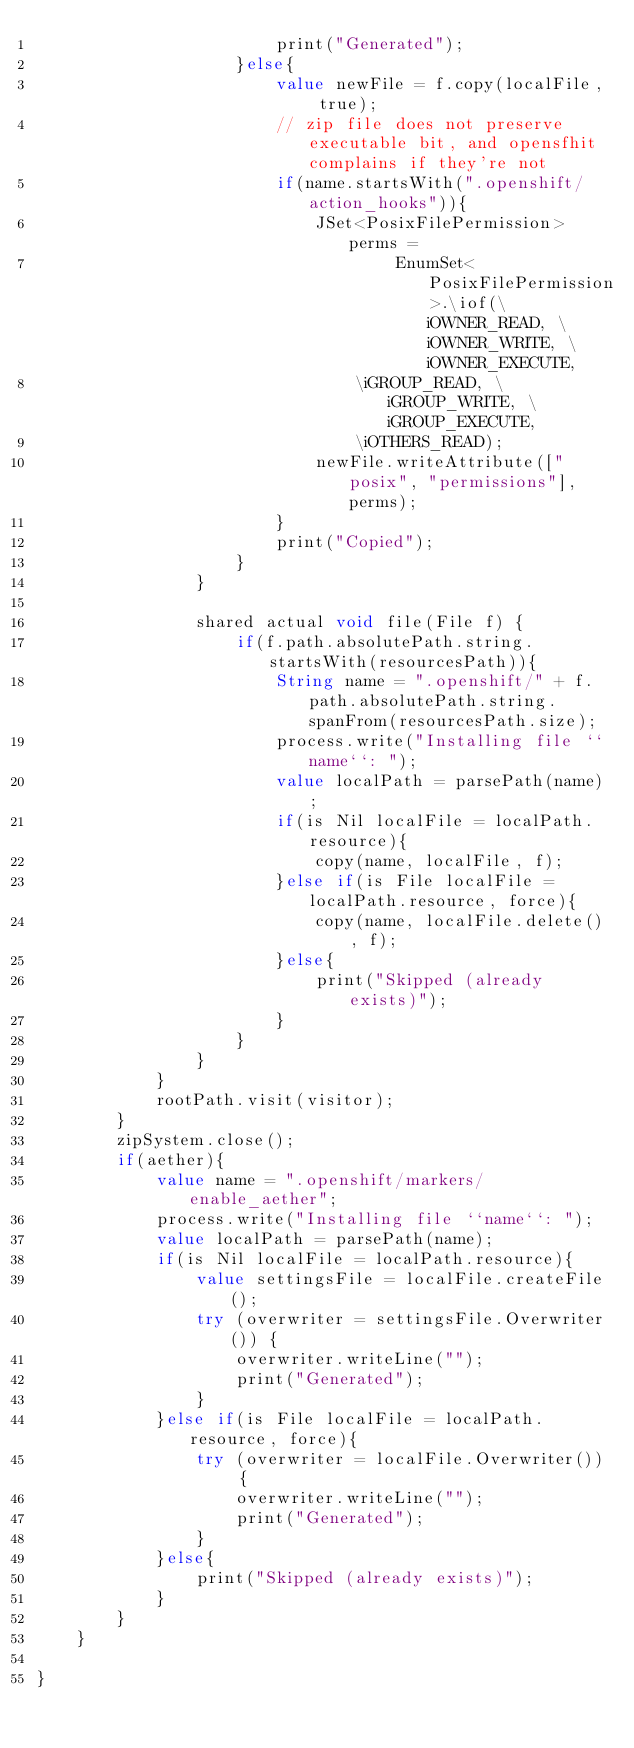<code> <loc_0><loc_0><loc_500><loc_500><_Ceylon_>                        print("Generated");
                    }else{
                        value newFile = f.copy(localFile, true);
                        // zip file does not preserve executable bit, and opensfhit complains if they're not
                        if(name.startsWith(".openshift/action_hooks")){
                            JSet<PosixFilePermission> perms =
                                    EnumSet<PosixFilePermission>.\iof(\iOWNER_READ, \iOWNER_WRITE, \iOWNER_EXECUTE, 
                                \iGROUP_READ, \iGROUP_WRITE, \iGROUP_EXECUTE,
                                \iOTHERS_READ);
                            newFile.writeAttribute(["posix", "permissions"], perms);
                        }
                        print("Copied");
                    }
                }
                
                shared actual void file(File f) {
                    if(f.path.absolutePath.string.startsWith(resourcesPath)){
                        String name = ".openshift/" + f.path.absolutePath.string.spanFrom(resourcesPath.size);
                        process.write("Installing file ``name``: ");
                        value localPath = parsePath(name);
                        if(is Nil localFile = localPath.resource){
                            copy(name, localFile, f);
                        }else if(is File localFile = localPath.resource, force){
                            copy(name, localFile.delete(), f);
                        }else{
                            print("Skipped (already exists)");
                        }
                    } 
                }
            }
            rootPath.visit(visitor);
        }
        zipSystem.close();
        if(aether){
            value name = ".openshift/markers/enable_aether";
            process.write("Installing file ``name``: ");
            value localPath = parsePath(name);
            if(is Nil localFile = localPath.resource){
                value settingsFile = localFile.createFile();
                try (overwriter = settingsFile.Overwriter()) {
                    overwriter.writeLine("");
                    print("Generated");
                }
            }else if(is File localFile = localPath.resource, force){
                try (overwriter = localFile.Overwriter()) {
                    overwriter.writeLine("");
                    print("Generated");
                }
            }else{
                print("Skipped (already exists)");
            }
        }
    }
    
}</code> 